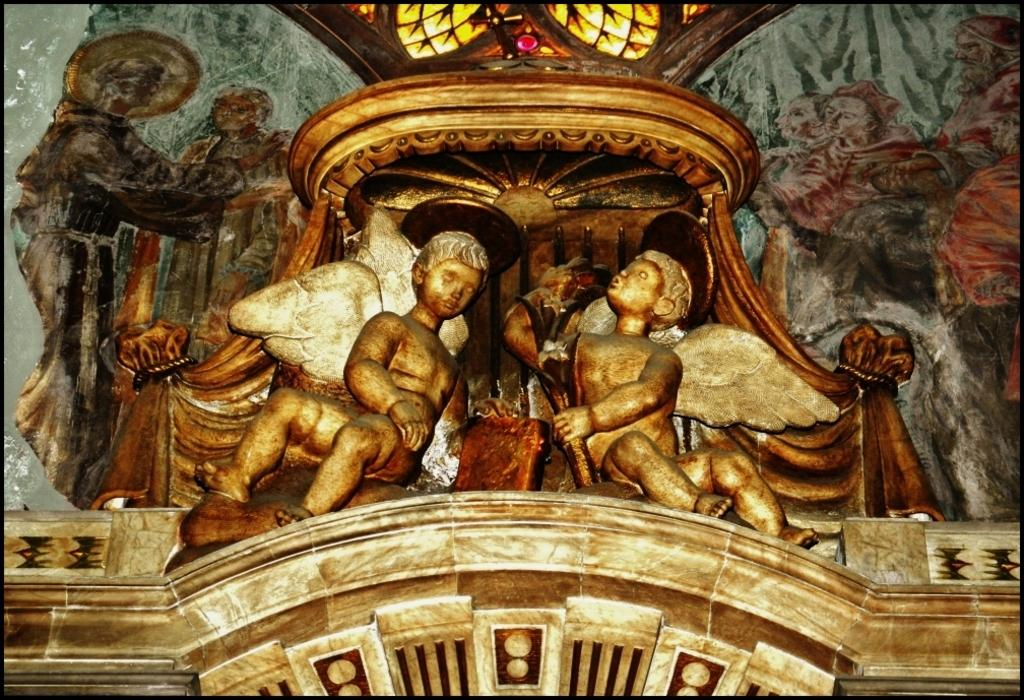What is depicted on the wall in the image? There is a wall with painting and design in the image. What type of artwork can be seen on the wall? There are sculptures on the wall. Are there any openings in the wall? Yes, there are windows at the top of the wall. What type of bun is being used to support the sculptures on the wall? There is no bun present in the image; the sculptures are supported by the wall itself. 